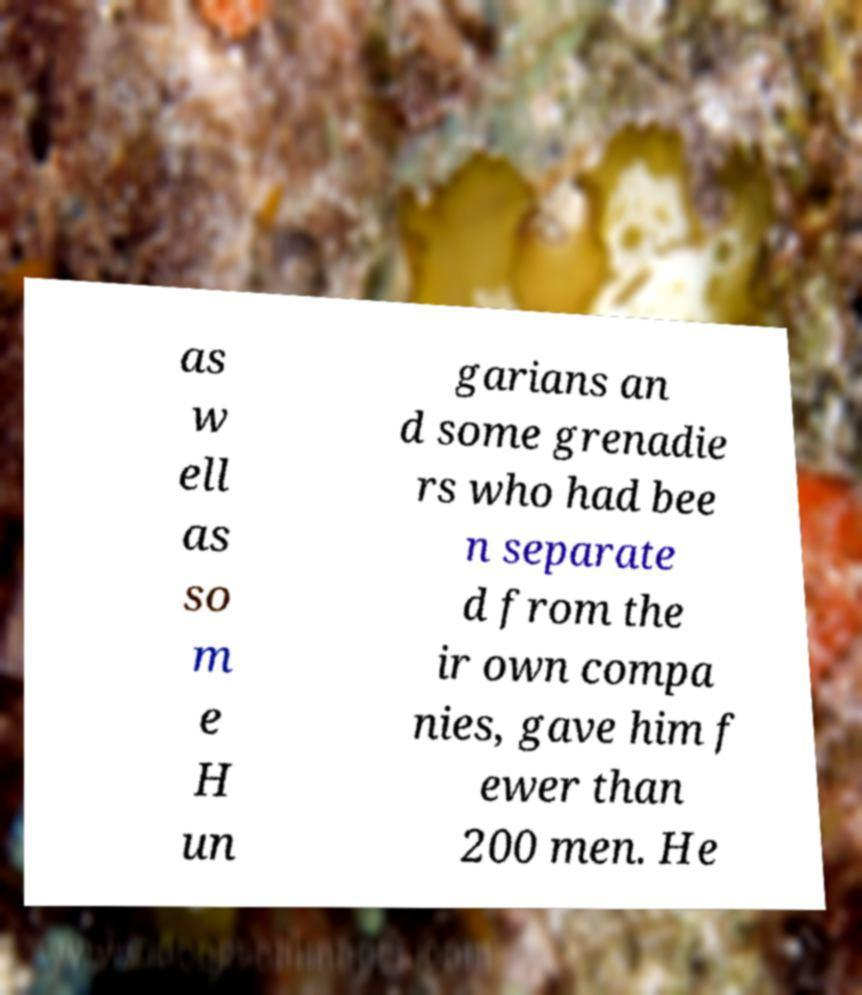What messages or text are displayed in this image? I need them in a readable, typed format. as w ell as so m e H un garians an d some grenadie rs who had bee n separate d from the ir own compa nies, gave him f ewer than 200 men. He 